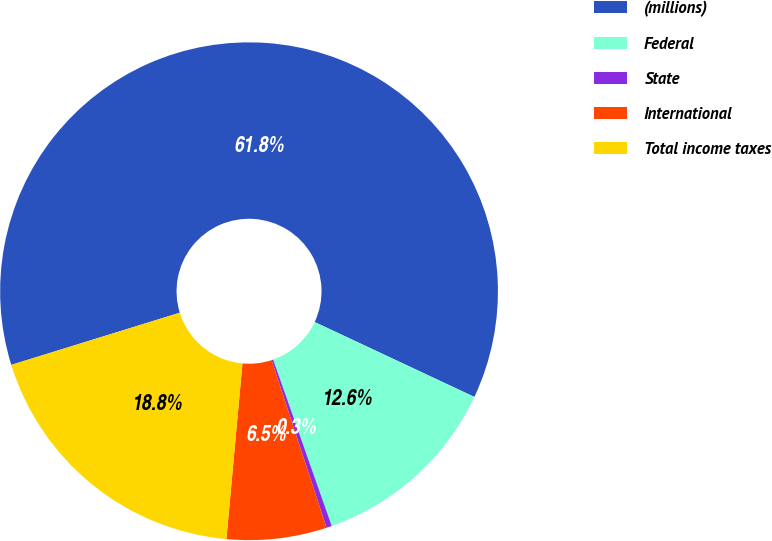Convert chart to OTSL. <chart><loc_0><loc_0><loc_500><loc_500><pie_chart><fcel>(millions)<fcel>Federal<fcel>State<fcel>International<fcel>Total income taxes<nl><fcel>61.76%<fcel>12.63%<fcel>0.35%<fcel>6.49%<fcel>18.77%<nl></chart> 